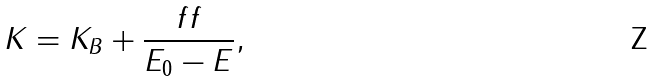Convert formula to latex. <formula><loc_0><loc_0><loc_500><loc_500>K = K _ { B } + \frac { f f } { E _ { 0 } - E } ,</formula> 